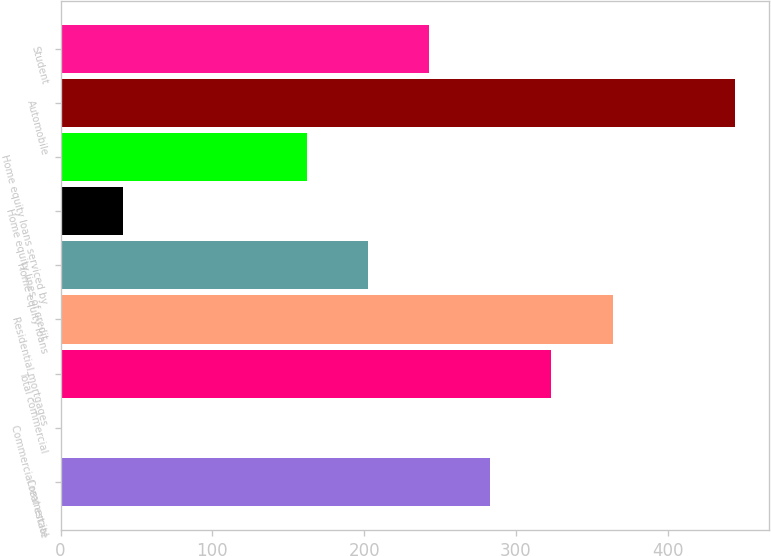<chart> <loc_0><loc_0><loc_500><loc_500><bar_chart><fcel>Commercial<fcel>Commercial real estate<fcel>Total commercial<fcel>Residential mortgages<fcel>Home equity loans<fcel>Home equity lines of credit<fcel>Home equity loans serviced by<fcel>Automobile<fcel>Student<nl><fcel>283.1<fcel>1<fcel>323.4<fcel>363.7<fcel>202.5<fcel>41.3<fcel>162.2<fcel>444.3<fcel>242.8<nl></chart> 